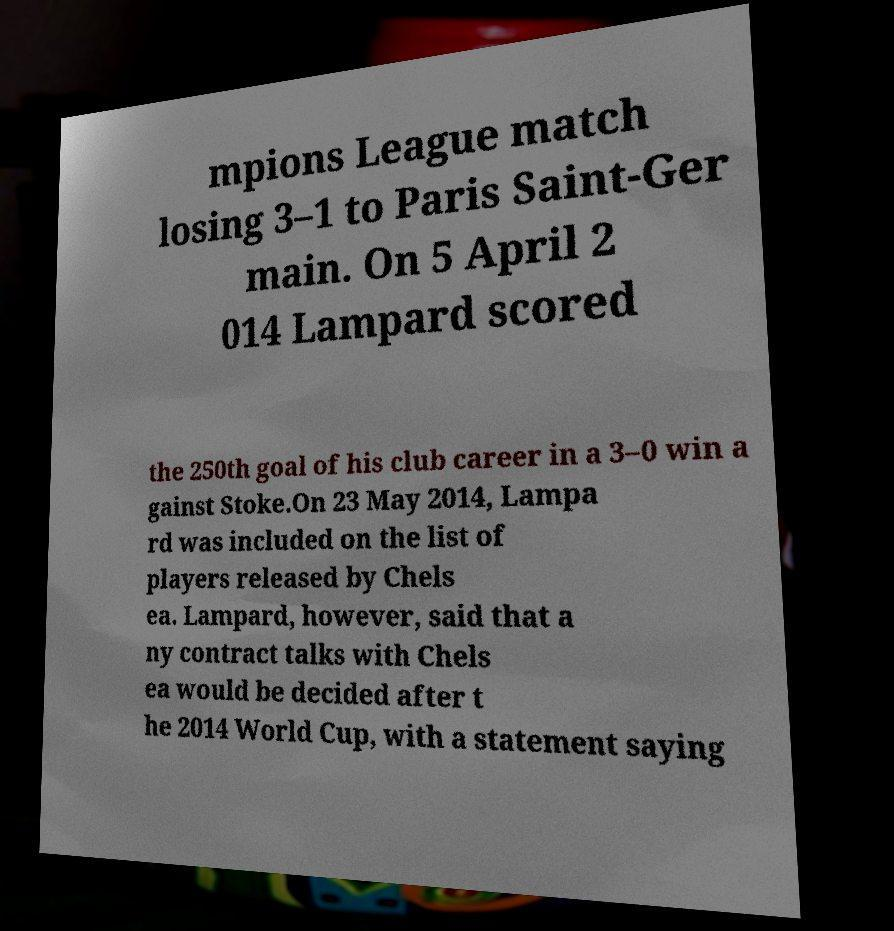Could you extract and type out the text from this image? mpions League match losing 3–1 to Paris Saint-Ger main. On 5 April 2 014 Lampard scored the 250th goal of his club career in a 3–0 win a gainst Stoke.On 23 May 2014, Lampa rd was included on the list of players released by Chels ea. Lampard, however, said that a ny contract talks with Chels ea would be decided after t he 2014 World Cup, with a statement saying 